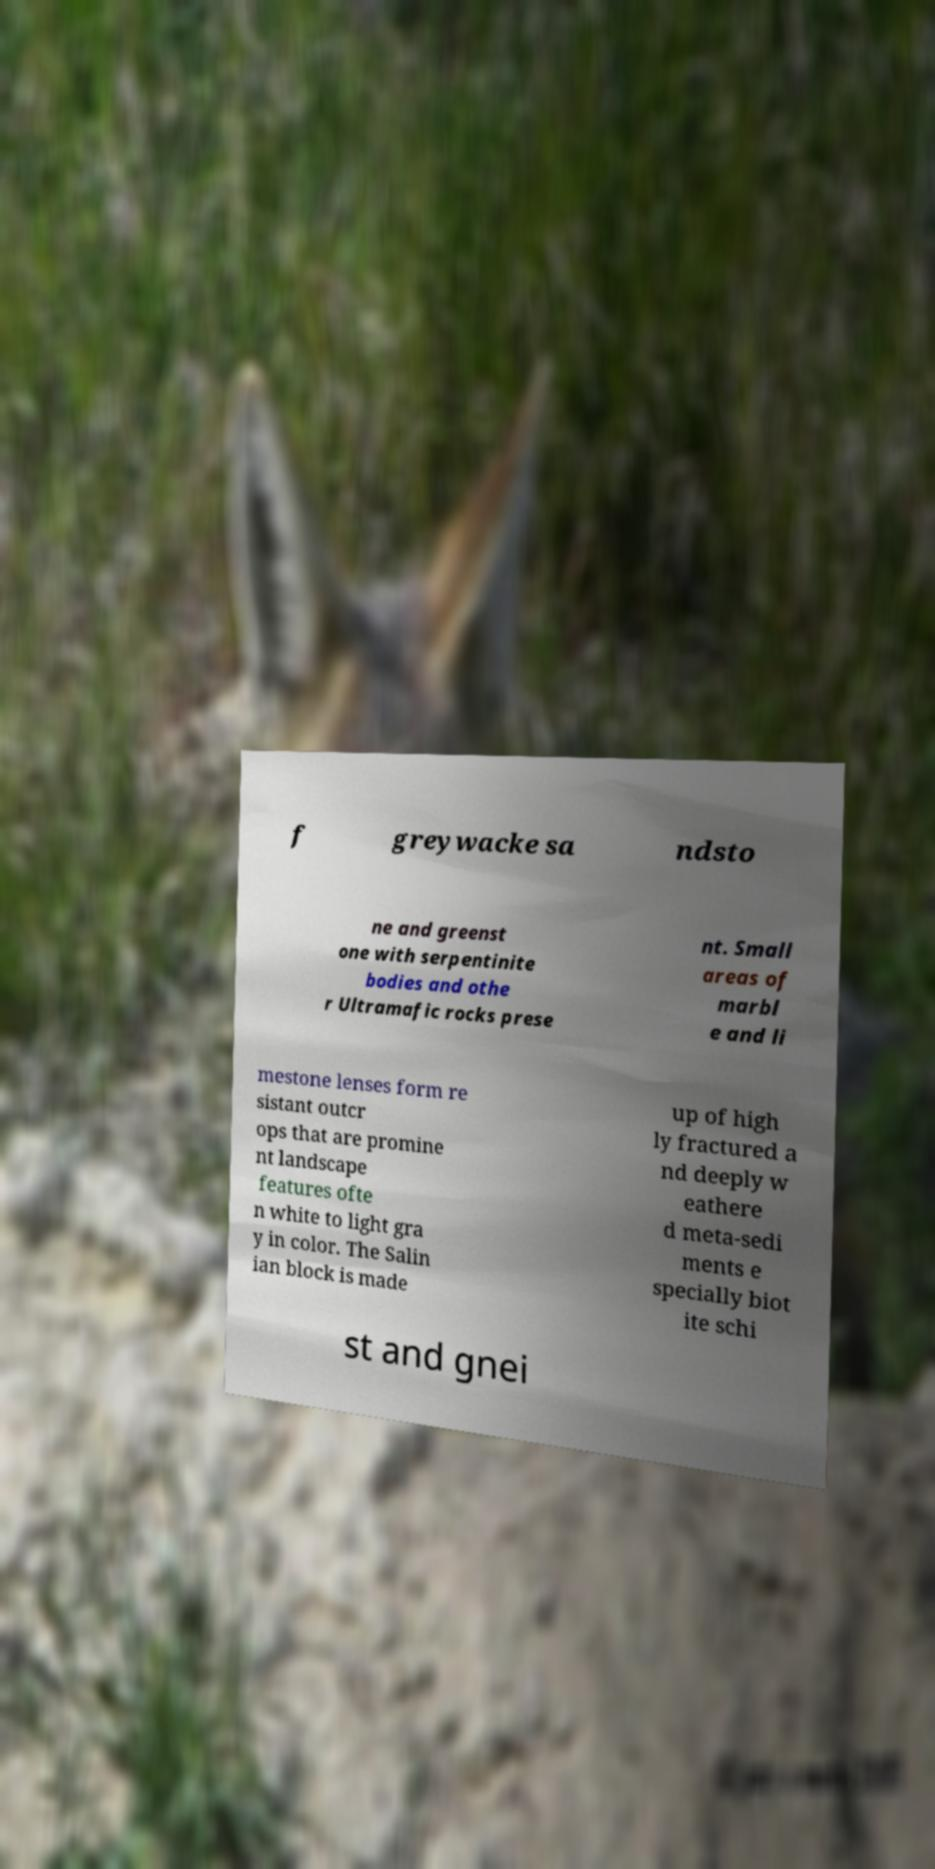What messages or text are displayed in this image? I need them in a readable, typed format. f greywacke sa ndsto ne and greenst one with serpentinite bodies and othe r Ultramafic rocks prese nt. Small areas of marbl e and li mestone lenses form re sistant outcr ops that are promine nt landscape features ofte n white to light gra y in color. The Salin ian block is made up of high ly fractured a nd deeply w eathere d meta-sedi ments e specially biot ite schi st and gnei 